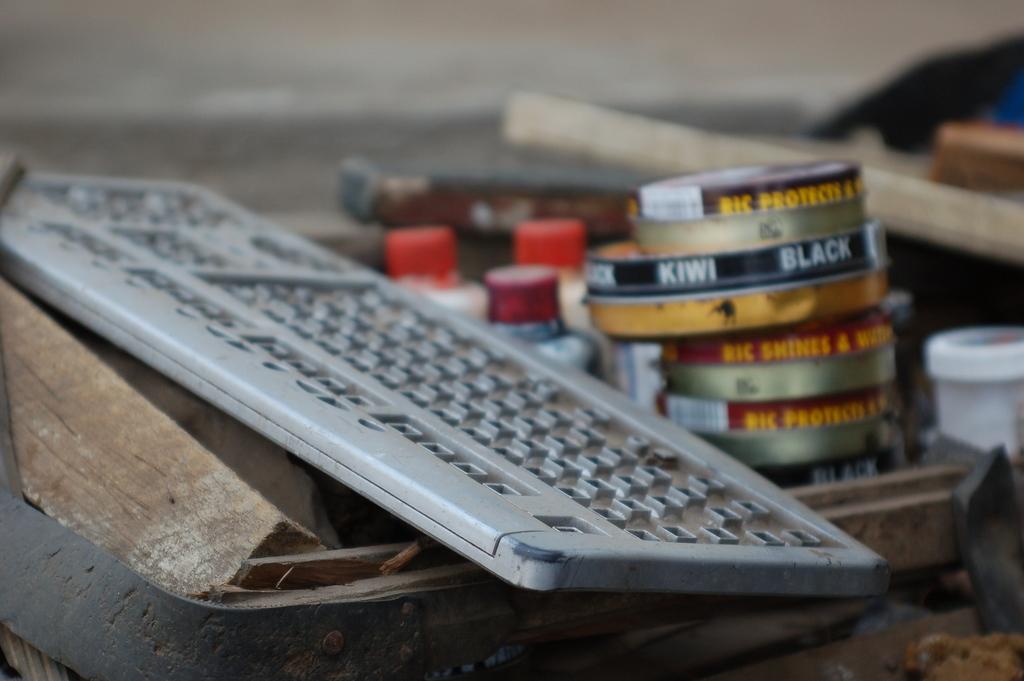What does the black label can say?
Keep it short and to the point. Kiwi black. Which brand is featured most on the cans?
Give a very brief answer. Kiwi. 